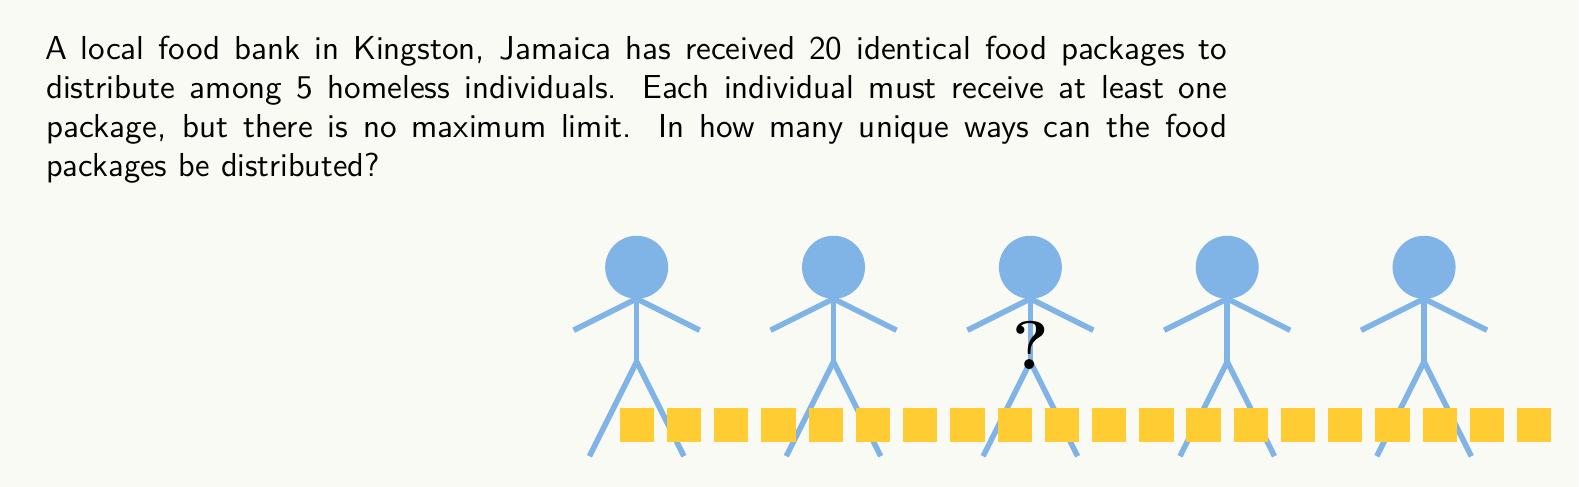Give your solution to this math problem. Let's approach this step-by-step using the concept of stars and bars (also known as balls and urns):

1) We have 20 identical food packages (stars) to distribute among 5 homeless individuals (spaces between bars).

2) The key formula for this scenario is:
   $${n+k-1 \choose k-1}$$
   where $n$ is the number of identical objects (food packages) and $k$ is the number of groups (homeless individuals).

3) In our case:
   $n = 20$ (food packages)
   $k = 5$ (homeless individuals)

4) Plugging these values into the formula:
   $${20+5-1 \choose 5-1} = {24 \choose 4}$$

5) Expanding this combination:
   $${24 \choose 4} = \frac{24!}{4!(24-4)!} = \frac{24!}{4!20!}$$

6) Calculate:
   $$\frac{24 \times 23 \times 22 \times 21}{4 \times 3 \times 2 \times 1} = 10,626$$

Therefore, there are 10,626 unique ways to distribute the food packages.
Answer: 10,626 